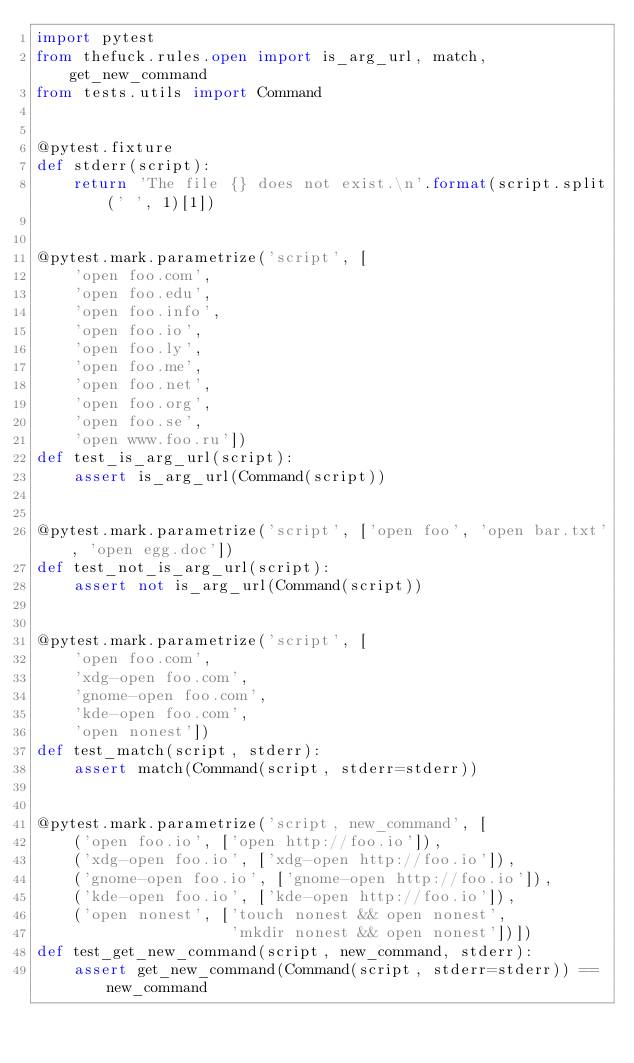<code> <loc_0><loc_0><loc_500><loc_500><_Python_>import pytest
from thefuck.rules.open import is_arg_url, match, get_new_command
from tests.utils import Command


@pytest.fixture
def stderr(script):
    return 'The file {} does not exist.\n'.format(script.split(' ', 1)[1])


@pytest.mark.parametrize('script', [
    'open foo.com',
    'open foo.edu',
    'open foo.info',
    'open foo.io',
    'open foo.ly',
    'open foo.me',
    'open foo.net',
    'open foo.org',
    'open foo.se',
    'open www.foo.ru'])
def test_is_arg_url(script):
    assert is_arg_url(Command(script))


@pytest.mark.parametrize('script', ['open foo', 'open bar.txt', 'open egg.doc'])
def test_not_is_arg_url(script):
    assert not is_arg_url(Command(script))


@pytest.mark.parametrize('script', [
    'open foo.com',
    'xdg-open foo.com',
    'gnome-open foo.com',
    'kde-open foo.com',
    'open nonest'])
def test_match(script, stderr):
    assert match(Command(script, stderr=stderr))


@pytest.mark.parametrize('script, new_command', [
    ('open foo.io', ['open http://foo.io']),
    ('xdg-open foo.io', ['xdg-open http://foo.io']),
    ('gnome-open foo.io', ['gnome-open http://foo.io']),
    ('kde-open foo.io', ['kde-open http://foo.io']),
    ('open nonest', ['touch nonest && open nonest',
                     'mkdir nonest && open nonest'])])
def test_get_new_command(script, new_command, stderr):
    assert get_new_command(Command(script, stderr=stderr)) == new_command
</code> 